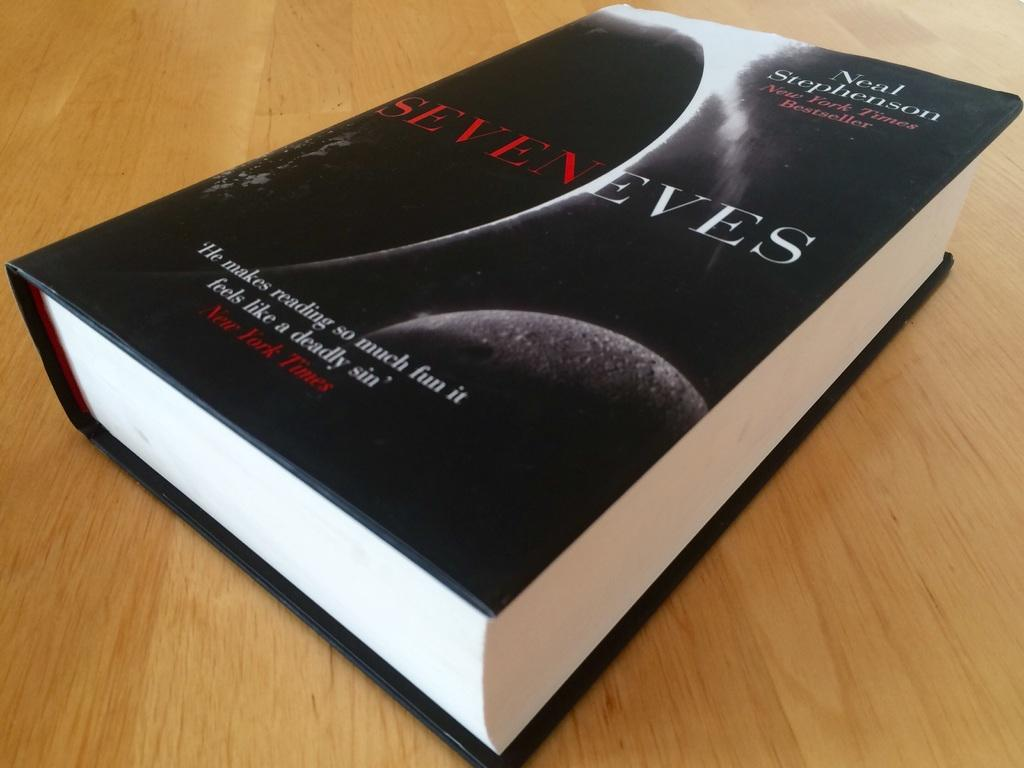<image>
Provide a brief description of the given image. A copy of the book Seven Eves sits on a wood table. 